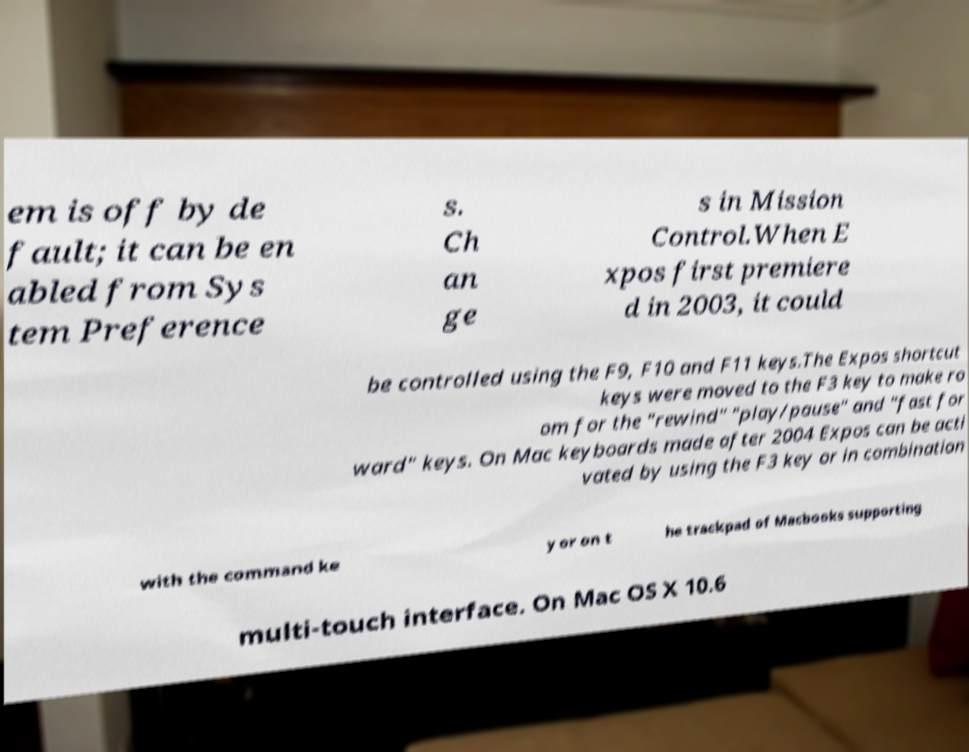I need the written content from this picture converted into text. Can you do that? em is off by de fault; it can be en abled from Sys tem Preference s. Ch an ge s in Mission Control.When E xpos first premiere d in 2003, it could be controlled using the F9, F10 and F11 keys.The Expos shortcut keys were moved to the F3 key to make ro om for the "rewind" "play/pause" and "fast for ward" keys. On Mac keyboards made after 2004 Expos can be acti vated by using the F3 key or in combination with the command ke y or on t he trackpad of Macbooks supporting multi-touch interface. On Mac OS X 10.6 